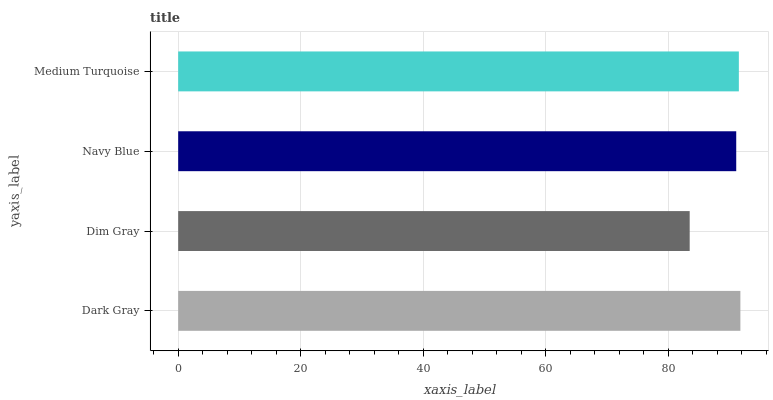Is Dim Gray the minimum?
Answer yes or no. Yes. Is Dark Gray the maximum?
Answer yes or no. Yes. Is Navy Blue the minimum?
Answer yes or no. No. Is Navy Blue the maximum?
Answer yes or no. No. Is Navy Blue greater than Dim Gray?
Answer yes or no. Yes. Is Dim Gray less than Navy Blue?
Answer yes or no. Yes. Is Dim Gray greater than Navy Blue?
Answer yes or no. No. Is Navy Blue less than Dim Gray?
Answer yes or no. No. Is Medium Turquoise the high median?
Answer yes or no. Yes. Is Navy Blue the low median?
Answer yes or no. Yes. Is Navy Blue the high median?
Answer yes or no. No. Is Dark Gray the low median?
Answer yes or no. No. 